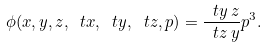<formula> <loc_0><loc_0><loc_500><loc_500>\phi ( x , y , z , \ t x , \ t y , \ t z , p ) = \frac { \ t y \, z } { \ t z \, y } p ^ { 3 } .</formula> 